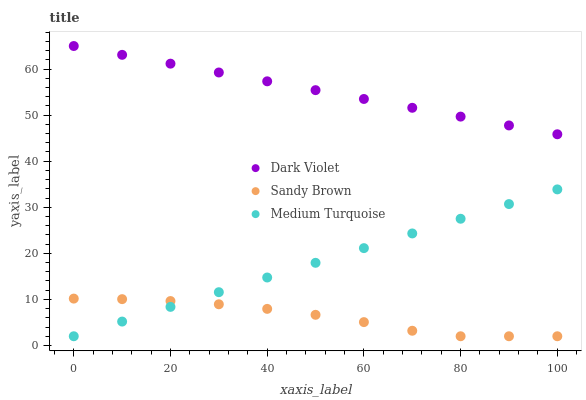Does Sandy Brown have the minimum area under the curve?
Answer yes or no. Yes. Does Dark Violet have the maximum area under the curve?
Answer yes or no. Yes. Does Medium Turquoise have the minimum area under the curve?
Answer yes or no. No. Does Medium Turquoise have the maximum area under the curve?
Answer yes or no. No. Is Dark Violet the smoothest?
Answer yes or no. Yes. Is Sandy Brown the roughest?
Answer yes or no. Yes. Is Medium Turquoise the smoothest?
Answer yes or no. No. Is Medium Turquoise the roughest?
Answer yes or no. No. Does Sandy Brown have the lowest value?
Answer yes or no. Yes. Does Dark Violet have the lowest value?
Answer yes or no. No. Does Dark Violet have the highest value?
Answer yes or no. Yes. Does Medium Turquoise have the highest value?
Answer yes or no. No. Is Sandy Brown less than Dark Violet?
Answer yes or no. Yes. Is Dark Violet greater than Medium Turquoise?
Answer yes or no. Yes. Does Sandy Brown intersect Medium Turquoise?
Answer yes or no. Yes. Is Sandy Brown less than Medium Turquoise?
Answer yes or no. No. Is Sandy Brown greater than Medium Turquoise?
Answer yes or no. No. Does Sandy Brown intersect Dark Violet?
Answer yes or no. No. 